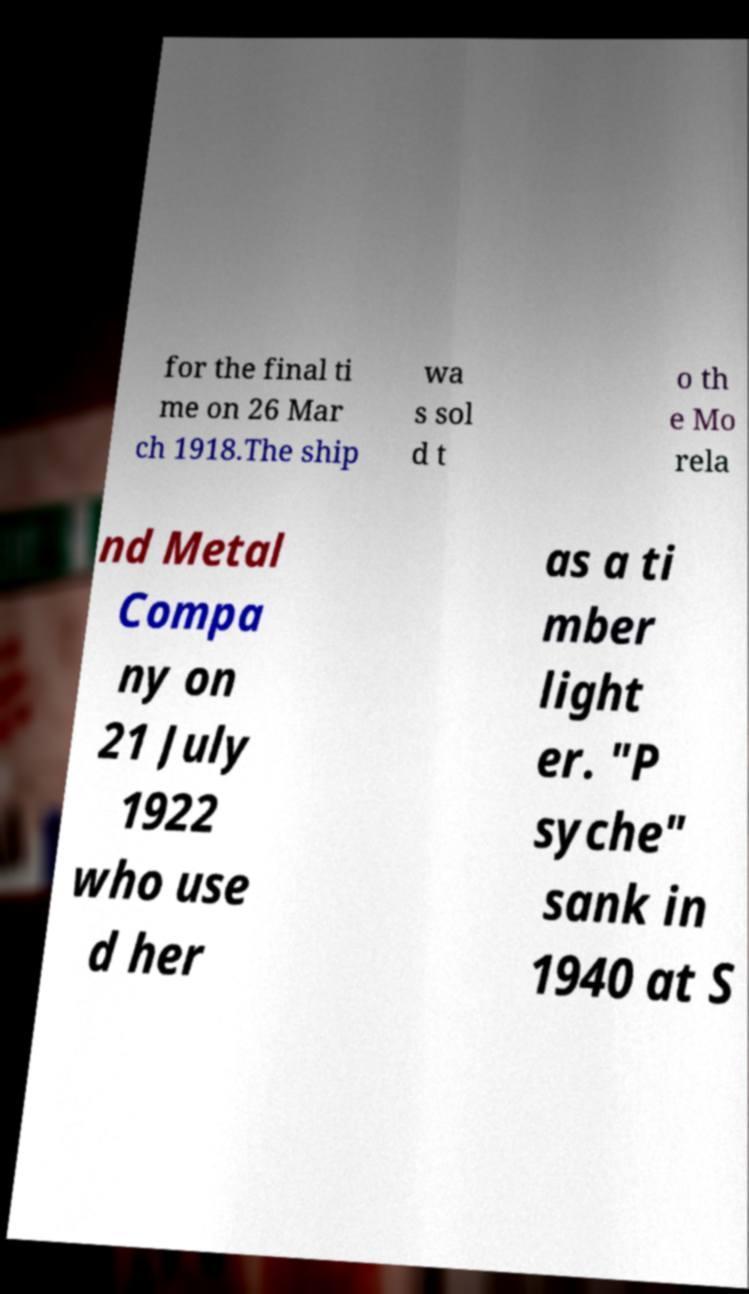Can you accurately transcribe the text from the provided image for me? for the final ti me on 26 Mar ch 1918.The ship wa s sol d t o th e Mo rela nd Metal Compa ny on 21 July 1922 who use d her as a ti mber light er. "P syche" sank in 1940 at S 